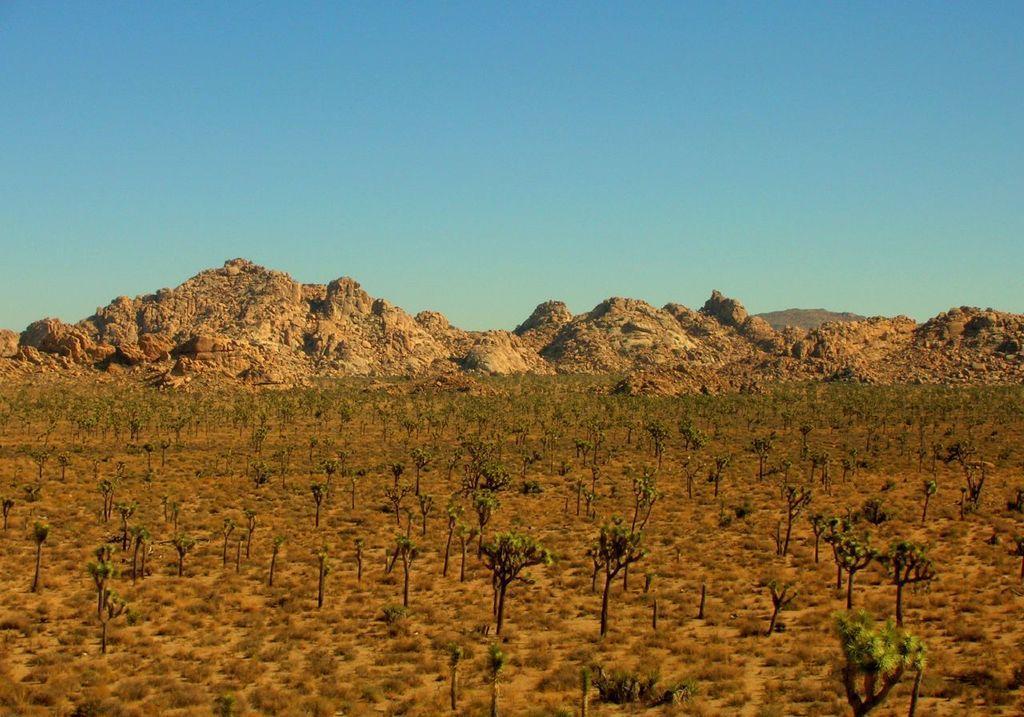Can you describe this image briefly? In this image, we can see few plants, grass, ground, mountains. Background there is a clear sky. 